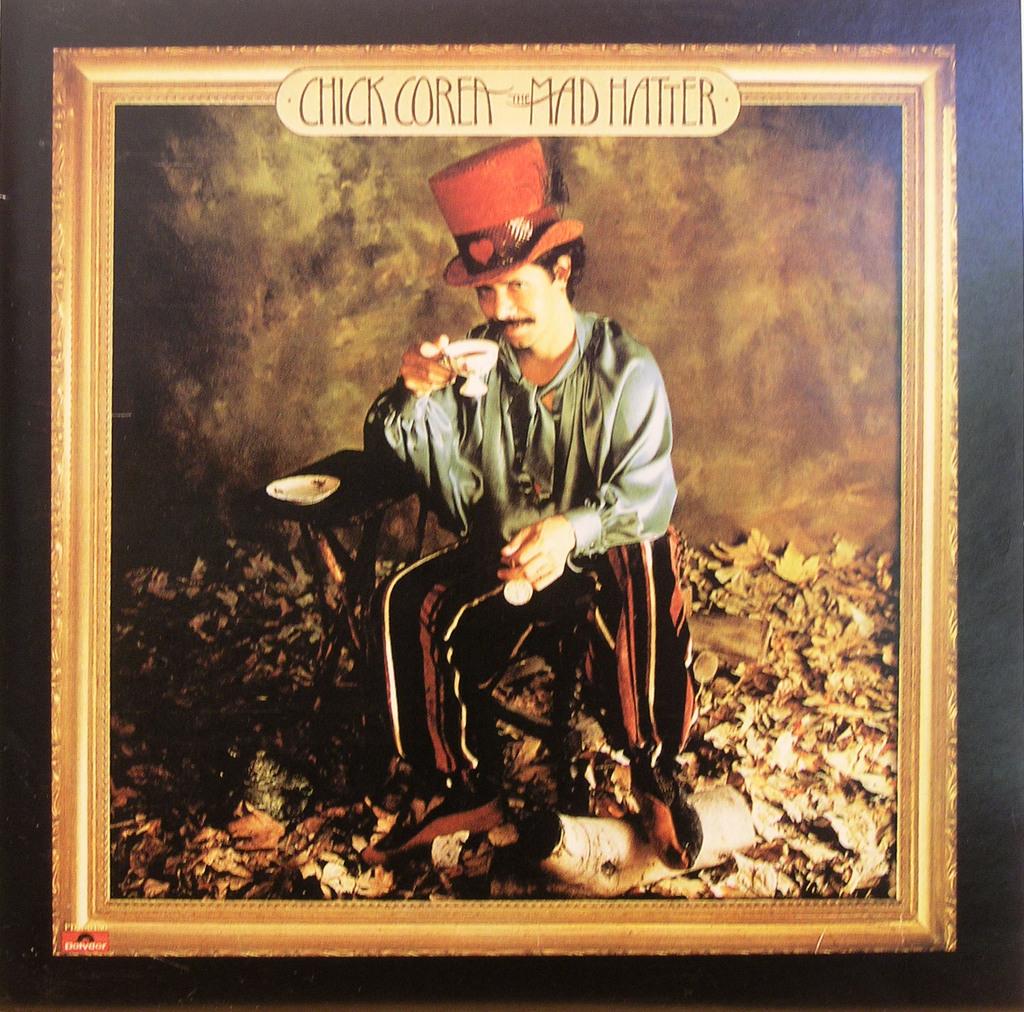Who played the mad hatter?
Your response must be concise. Chick corea. Is this a photo of the mad hatter?
Your answer should be compact. Yes. 